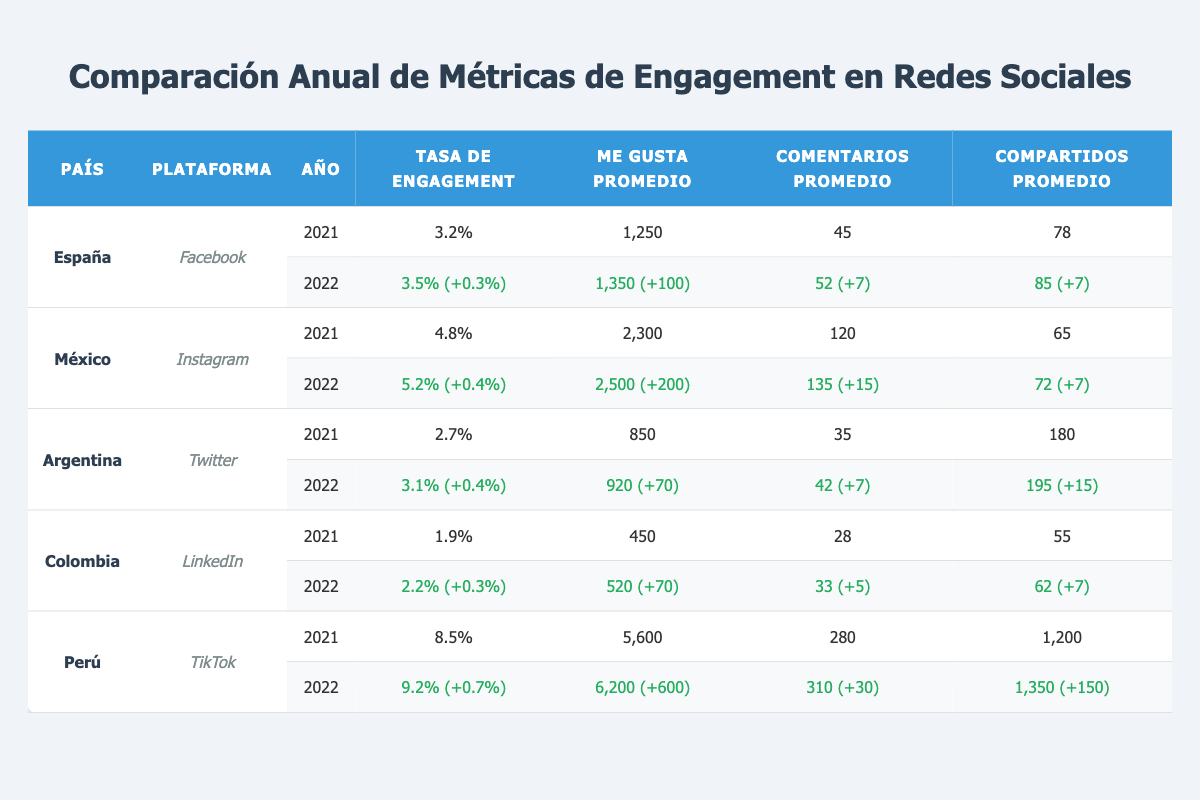¿Cuál es el país con la tasa de engagement más alta en 2021? En la tabla, observamos que Perú tiene la tasa de engagement más alta de 8.5% en 2021, comparado con otros países que tienen tasas menores.
Answer: Perú ¿Qué plataforma tuvo el mayor número promedio de "me gusta" en 2022? En 2022, Perú en TikTok tuvo el mayor promedio de "me gusta" con 6200, superando a otras plataformas y países.
Answer: TikTok ¿Cuánto aumentó la tasa de engagement de Argentina de 2021 a 2022? La tasa de engagement para Argentina fue 2.7% en 2021 y subió a 3.1% en 2022. La diferencia es 3.1% - 2.7% = 0.4%.
Answer: 0.4% ¿Es verdad que España tuvo más comentarios promedio en Facebook en 2022 que en 2021? En 2021, el promedio de comentarios fue 45 y en 2022 fue 52. 52 es mayor que 45, por lo tanto, es verdadero.
Answer: Sí ¿Qué país y plataforma tuvieron un incremento de "compartidos" promedio más significativo de 2021 a 2022? Comparando los datos, Perú en TikTok tuvo un incremento de 150 compartidos, subiendo de 1200 a 1350, siendo el mayor incremento entre todos los datos.
Answer: Perú en TikTok ¿Cuál es la tasa de engagement promedio de México en 2021 y 2022? En 2021, la tasa fue 4.8% y en 2022 fue 5.2%. Para calcular el promedio: (4.8% + 5.2%) / 2 = 5%.
Answer: 5% ¿Colombia tuvo una tasa de engagement en LinkedIn superior a 2% en 2022? En 2022, la tasa de engagement fue 2.2%, que es mayor a 2%. Por lo tanto, es verdadero.
Answer: Sí ¿Cuál fue la diferencia en el número de "me gusta" promedio de México entre 2021 y 2022? En 2021, el promedio de "me gusta" fue 2300 y en 2022 fue 2500. La diferencia es 2500 - 2300 = 200.
Answer: 200 ¿Qué país tuvo la tasa de engagement más baja en 2021 y cuál fue el valor? En 2021, Colombia tuvo la tasa de engagement más baja con 1.9%, comparado con otros países que tuvieron tasas más altas.
Answer: Colombia con 1.9% 